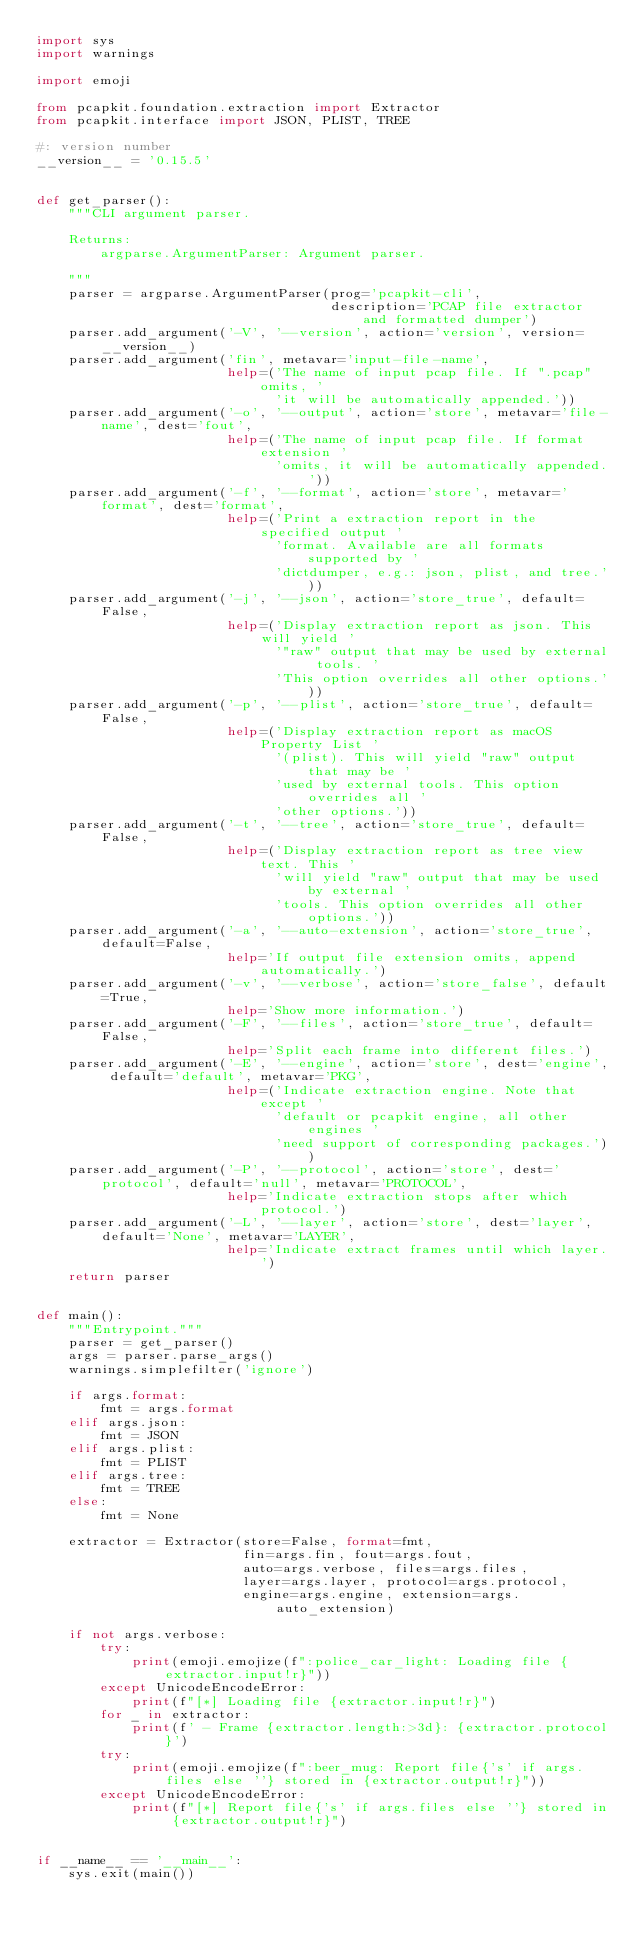Convert code to text. <code><loc_0><loc_0><loc_500><loc_500><_Python_>import sys
import warnings

import emoji

from pcapkit.foundation.extraction import Extractor
from pcapkit.interface import JSON, PLIST, TREE

#: version number
__version__ = '0.15.5'


def get_parser():
    """CLI argument parser.

    Returns:
        argparse.ArgumentParser: Argument parser.

    """
    parser = argparse.ArgumentParser(prog='pcapkit-cli',
                                     description='PCAP file extractor and formatted dumper')
    parser.add_argument('-V', '--version', action='version', version=__version__)
    parser.add_argument('fin', metavar='input-file-name',
                        help=('The name of input pcap file. If ".pcap" omits, '
                              'it will be automatically appended.'))
    parser.add_argument('-o', '--output', action='store', metavar='file-name', dest='fout',
                        help=('The name of input pcap file. If format extension '
                              'omits, it will be automatically appended.'))
    parser.add_argument('-f', '--format', action='store', metavar='format', dest='format',
                        help=('Print a extraction report in the specified output '
                              'format. Available are all formats supported by '
                              'dictdumper, e.g.: json, plist, and tree.'))
    parser.add_argument('-j', '--json', action='store_true', default=False,
                        help=('Display extraction report as json. This will yield '
                              '"raw" output that may be used by external tools. '
                              'This option overrides all other options.'))
    parser.add_argument('-p', '--plist', action='store_true', default=False,
                        help=('Display extraction report as macOS Property List '
                              '(plist). This will yield "raw" output that may be '
                              'used by external tools. This option overrides all '
                              'other options.'))
    parser.add_argument('-t', '--tree', action='store_true', default=False,
                        help=('Display extraction report as tree view text. This '
                              'will yield "raw" output that may be used by external '
                              'tools. This option overrides all other options.'))
    parser.add_argument('-a', '--auto-extension', action='store_true', default=False,
                        help='If output file extension omits, append automatically.')
    parser.add_argument('-v', '--verbose', action='store_false', default=True,
                        help='Show more information.')
    parser.add_argument('-F', '--files', action='store_true', default=False,
                        help='Split each frame into different files.')
    parser.add_argument('-E', '--engine', action='store', dest='engine', default='default', metavar='PKG',
                        help=('Indicate extraction engine. Note that except '
                              'default or pcapkit engine, all other engines '
                              'need support of corresponding packages.'))
    parser.add_argument('-P', '--protocol', action='store', dest='protocol', default='null', metavar='PROTOCOL',
                        help='Indicate extraction stops after which protocol.')
    parser.add_argument('-L', '--layer', action='store', dest='layer', default='None', metavar='LAYER',
                        help='Indicate extract frames until which layer.')
    return parser


def main():
    """Entrypoint."""
    parser = get_parser()
    args = parser.parse_args()
    warnings.simplefilter('ignore')

    if args.format:
        fmt = args.format
    elif args.json:
        fmt = JSON
    elif args.plist:
        fmt = PLIST
    elif args.tree:
        fmt = TREE
    else:
        fmt = None

    extractor = Extractor(store=False, format=fmt,
                          fin=args.fin, fout=args.fout,
                          auto=args.verbose, files=args.files,
                          layer=args.layer, protocol=args.protocol,
                          engine=args.engine, extension=args.auto_extension)

    if not args.verbose:
        try:
            print(emoji.emojize(f":police_car_light: Loading file {extractor.input!r}"))
        except UnicodeEncodeError:
            print(f"[*] Loading file {extractor.input!r}")
        for _ in extractor:
            print(f' - Frame {extractor.length:>3d}: {extractor.protocol}')
        try:
            print(emoji.emojize(f":beer_mug: Report file{'s' if args.files else ''} stored in {extractor.output!r}"))
        except UnicodeEncodeError:
            print(f"[*] Report file{'s' if args.files else ''} stored in {extractor.output!r}")


if __name__ == '__main__':
    sys.exit(main())
</code> 